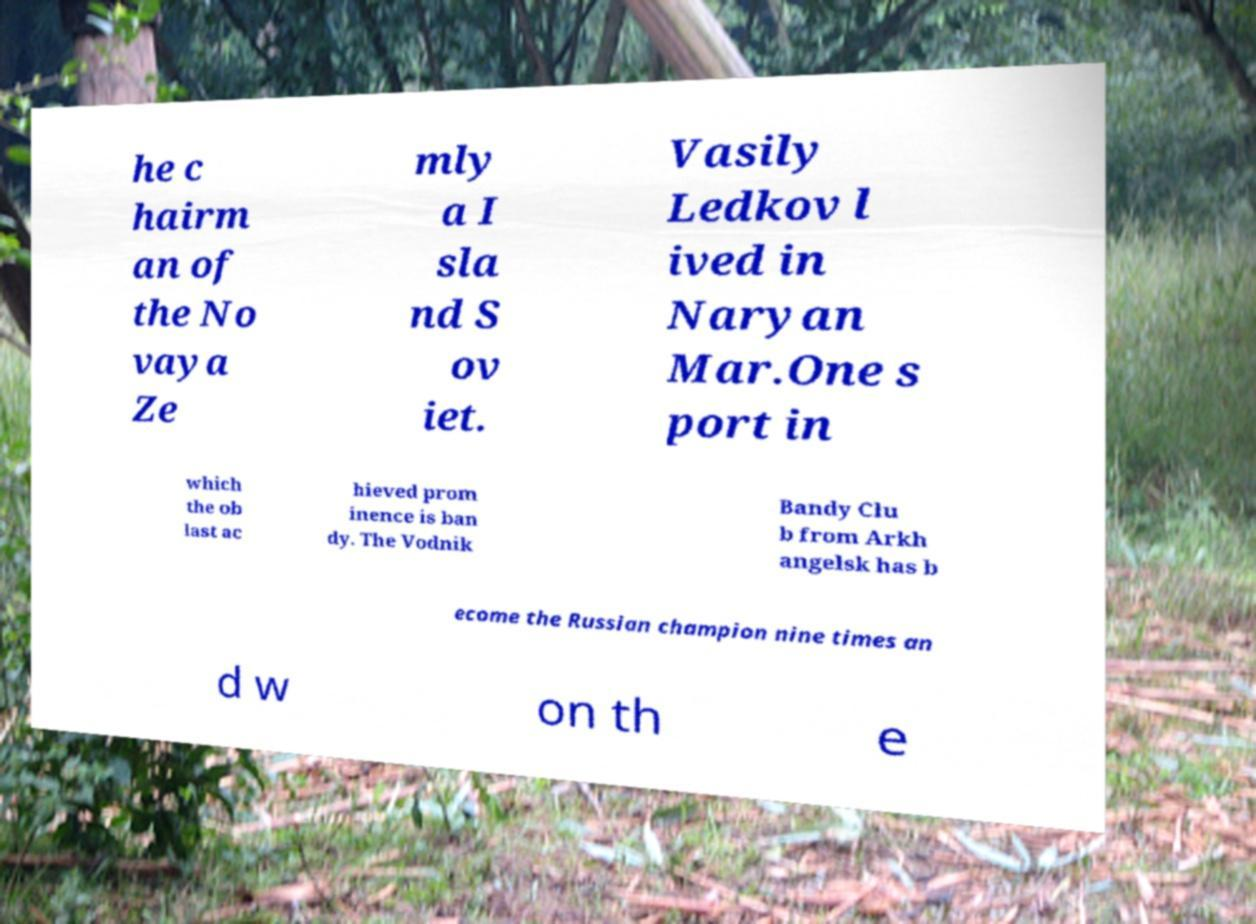What messages or text are displayed in this image? I need them in a readable, typed format. he c hairm an of the No vaya Ze mly a I sla nd S ov iet. Vasily Ledkov l ived in Naryan Mar.One s port in which the ob last ac hieved prom inence is ban dy. The Vodnik Bandy Clu b from Arkh angelsk has b ecome the Russian champion nine times an d w on th e 